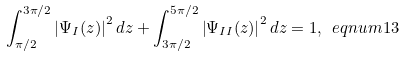Convert formula to latex. <formula><loc_0><loc_0><loc_500><loc_500>\int _ { \pi / 2 } ^ { 3 \pi / 2 } \left | \Psi _ { I } ( z ) \right | ^ { 2 } d z + \int _ { 3 \pi / 2 } ^ { 5 \pi / 2 } \left | \Psi _ { I I } ( z ) \right | ^ { 2 } d z = 1 , \ e q n u m { 1 3 }</formula> 